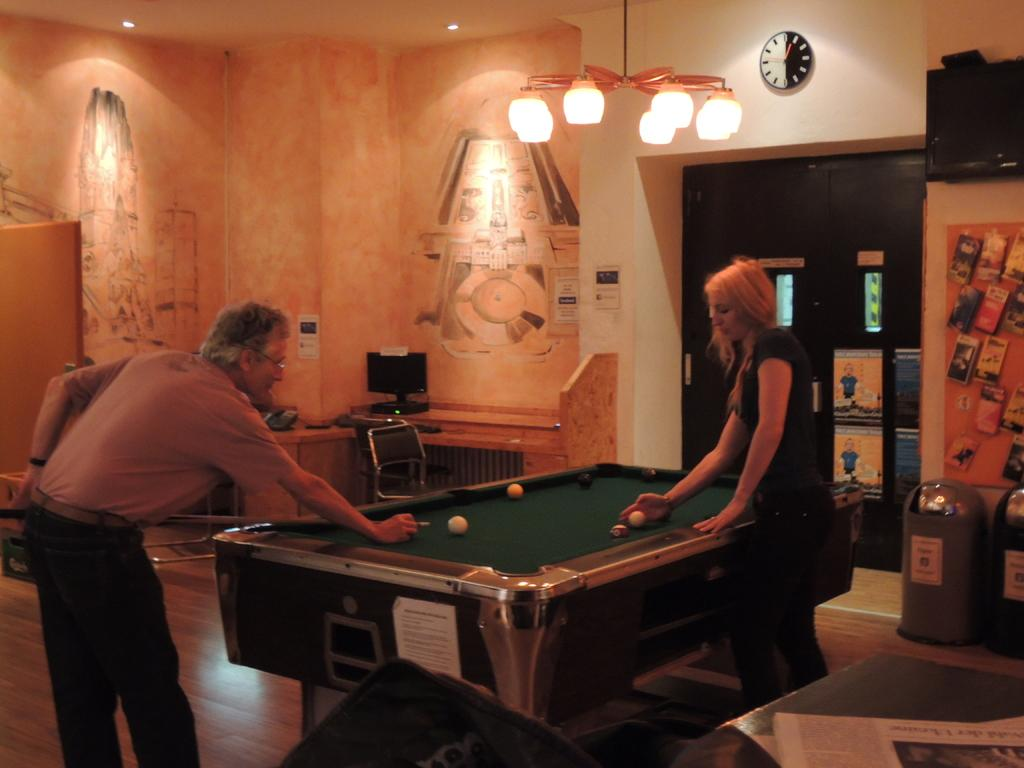How many people are in the image? There are two people in the image, a man and a woman. What are the man and woman doing in the image? Both the man and woman are standing on the floor. What is the main object in the room where the man and woman are standing? There is a snooker table in the image. What type of lighting fixture is present in the room? There is a chandelier in the image. What time-related object can be seen on the wall? There is a clock on the wall in the image. Can you see any sand in the image? No, there is no sand present in the image. Are there any deer visible in the image? No, there are no deer present in the image. 